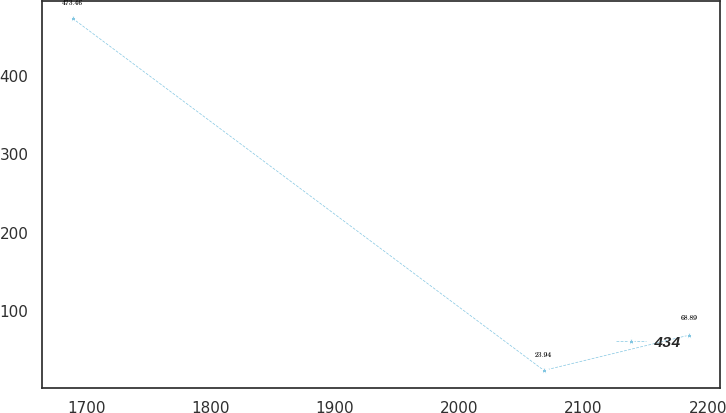Convert chart. <chart><loc_0><loc_0><loc_500><loc_500><line_chart><ecel><fcel>434<nl><fcel>1688.93<fcel>473.46<nl><fcel>2068.1<fcel>23.94<nl><fcel>2184.74<fcel>68.89<nl></chart> 